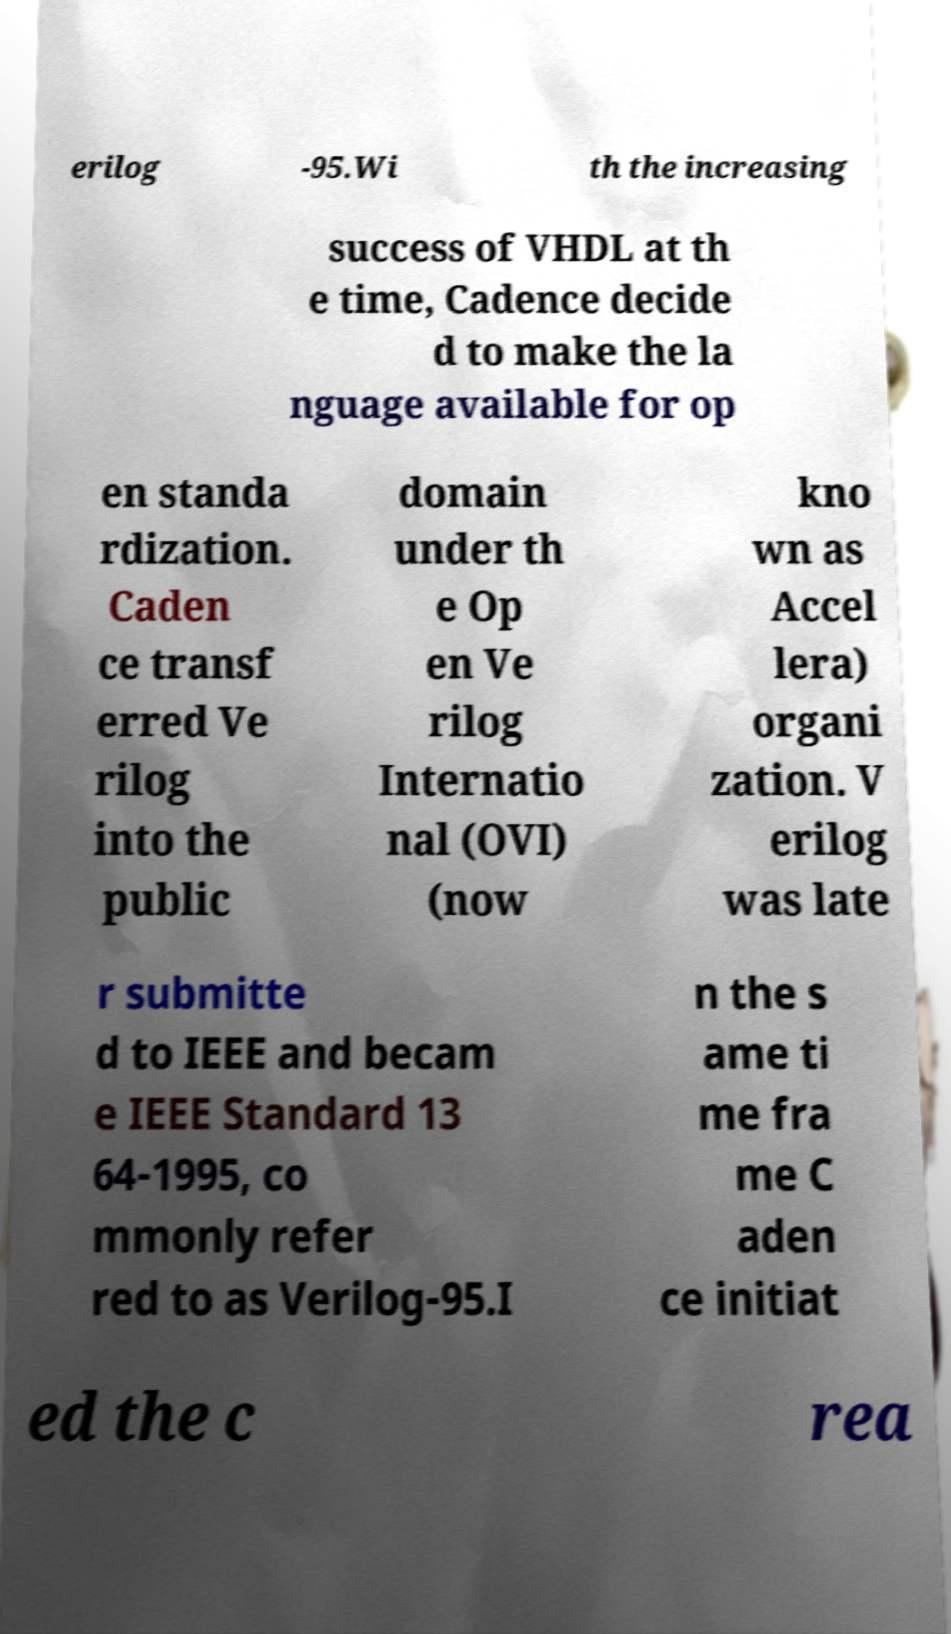Please identify and transcribe the text found in this image. erilog -95.Wi th the increasing success of VHDL at th e time, Cadence decide d to make the la nguage available for op en standa rdization. Caden ce transf erred Ve rilog into the public domain under th e Op en Ve rilog Internatio nal (OVI) (now kno wn as Accel lera) organi zation. V erilog was late r submitte d to IEEE and becam e IEEE Standard 13 64-1995, co mmonly refer red to as Verilog-95.I n the s ame ti me fra me C aden ce initiat ed the c rea 